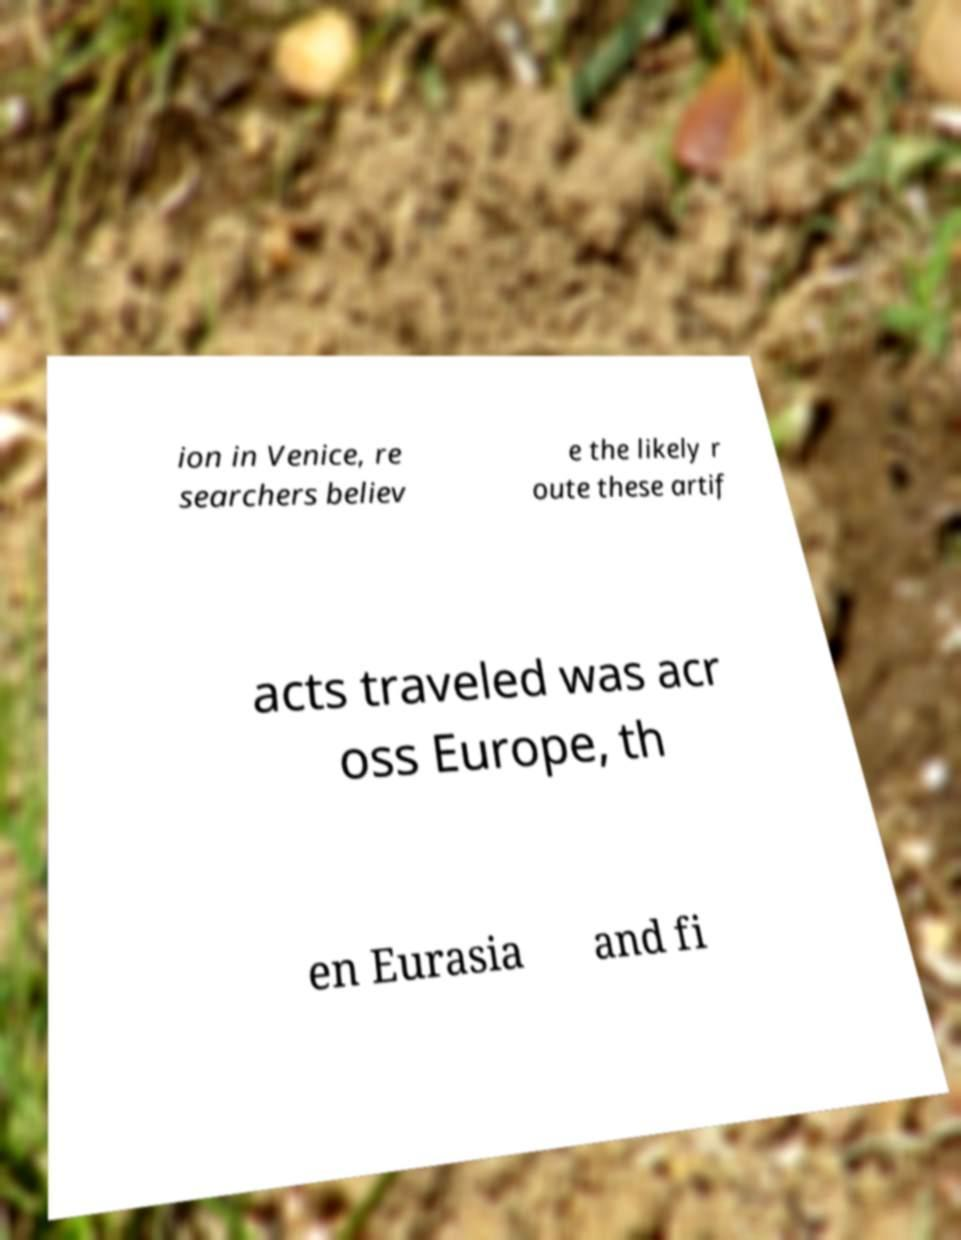What messages or text are displayed in this image? I need them in a readable, typed format. ion in Venice, re searchers believ e the likely r oute these artif acts traveled was acr oss Europe, th en Eurasia and fi 